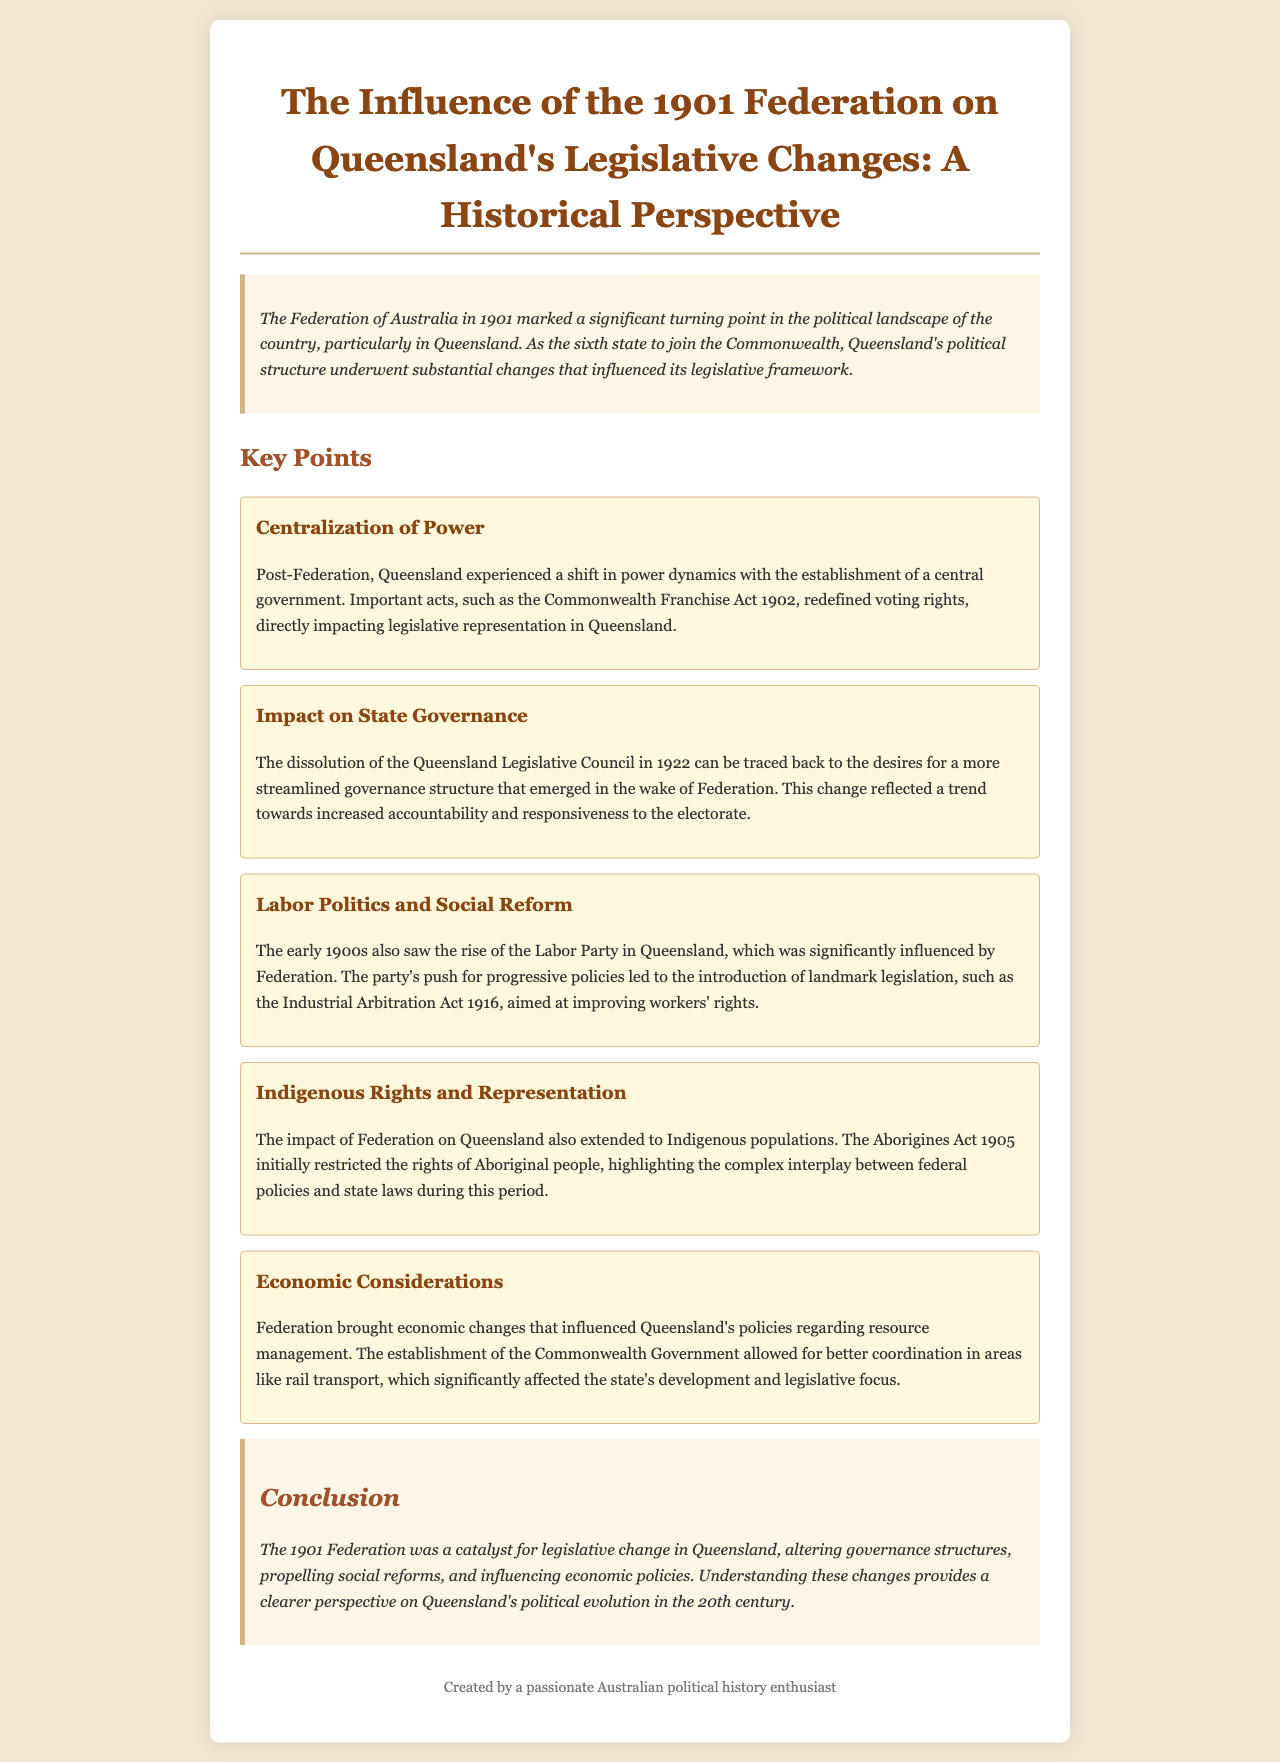What was the significant political shift after the 1901 Federation? The document mentions a shift in power dynamics with the establishment of a central government.
Answer: Centralization of Power Which act changed voting rights in Queensland post-Federation? The document cites the Commonwealth Franchise Act 1902 as important for redefining voting rights.
Answer: Commonwealth Franchise Act 1902 What major legislative change occurred in Queensland in 1922? The dissolution of the Queensland Legislative Council is mentioned as a significant event.
Answer: Dissolution of the Queensland Legislative Council What party rose to prominence in Queensland during the early 1900s? The document notes the rise of the Labor Party significantly influenced by Federation.
Answer: Labor Party What act aimed to improve workers' rights in Queensland? The Industrial Arbitration Act 1916 is highlighted as landmark legislation for workers' rights.
Answer: Industrial Arbitration Act 1916 Which act restricted the rights of Aboriginal people in Queensland? The document references the Aborigines Act 1905 as a law that initially restricted Aboriginal rights.
Answer: Aborigines Act 1905 How did Federation affect Queensland's economic policies? The document discusses better coordination in resource management and transport due to the establishment of the Commonwealth Government.
Answer: Economic Considerations What was the impact of Federation on Indigenous populations? The document indicates that the Aborigines Act 1905 highlights the interplay between federal policies and state laws affecting Indigenous populations.
Answer: Indigenous Rights and Representation What was a key social reform during the early 1900s in Queensland? The push for progressive policies by the Labor Party led to significant social reforms noted in the document.
Answer: Social Reform 